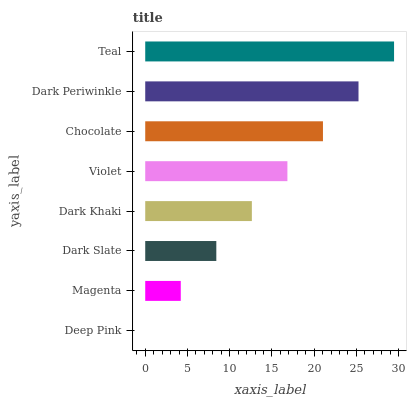Is Deep Pink the minimum?
Answer yes or no. Yes. Is Teal the maximum?
Answer yes or no. Yes. Is Magenta the minimum?
Answer yes or no. No. Is Magenta the maximum?
Answer yes or no. No. Is Magenta greater than Deep Pink?
Answer yes or no. Yes. Is Deep Pink less than Magenta?
Answer yes or no. Yes. Is Deep Pink greater than Magenta?
Answer yes or no. No. Is Magenta less than Deep Pink?
Answer yes or no. No. Is Violet the high median?
Answer yes or no. Yes. Is Dark Khaki the low median?
Answer yes or no. Yes. Is Teal the high median?
Answer yes or no. No. Is Dark Slate the low median?
Answer yes or no. No. 